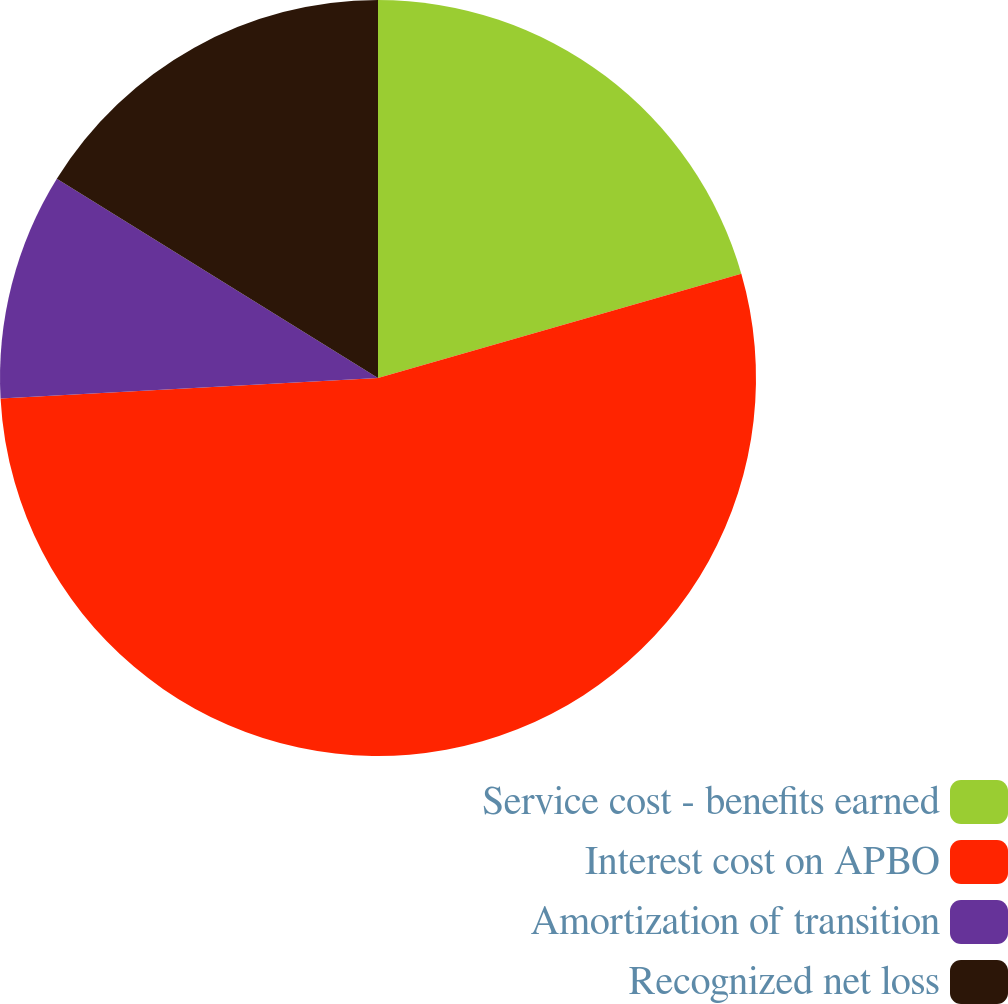Convert chart to OTSL. <chart><loc_0><loc_0><loc_500><loc_500><pie_chart><fcel>Service cost - benefits earned<fcel>Interest cost on APBO<fcel>Amortization of transition<fcel>Recognized net loss<nl><fcel>20.55%<fcel>53.59%<fcel>9.7%<fcel>16.16%<nl></chart> 